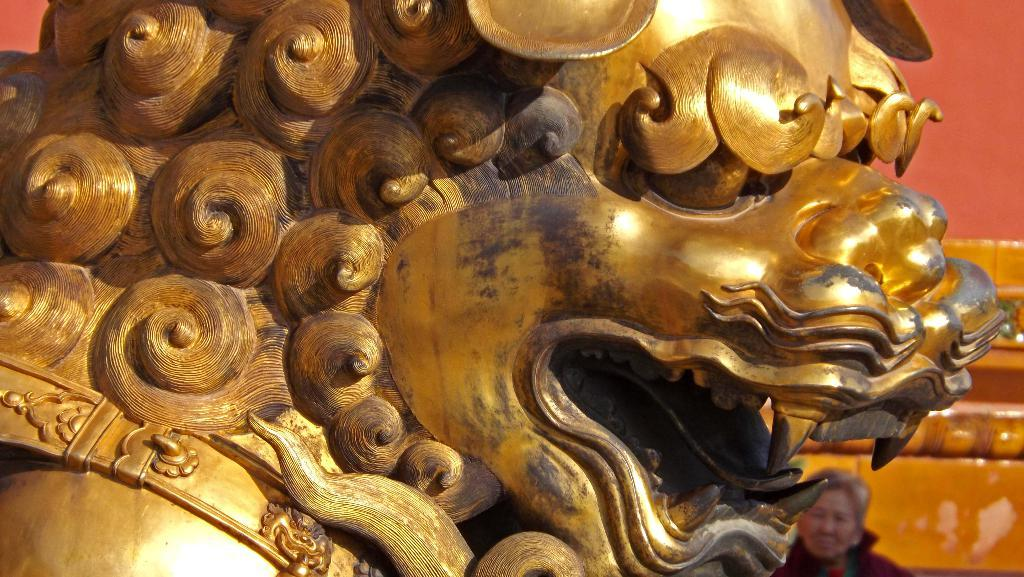What is the main subject in the image? There is a sculpture in the image. Are there any people in the image? Yes, there is a woman in the image. What can be seen in the background of the image? There is a wall visible in the background of the image. What type of fork can be seen in the woman's hand in the image? There is no fork present in the image. Is there a cactus growing on the wall in the background of the image? There is no cactus visible in the image; only the sculpture, woman, and wall are present. 